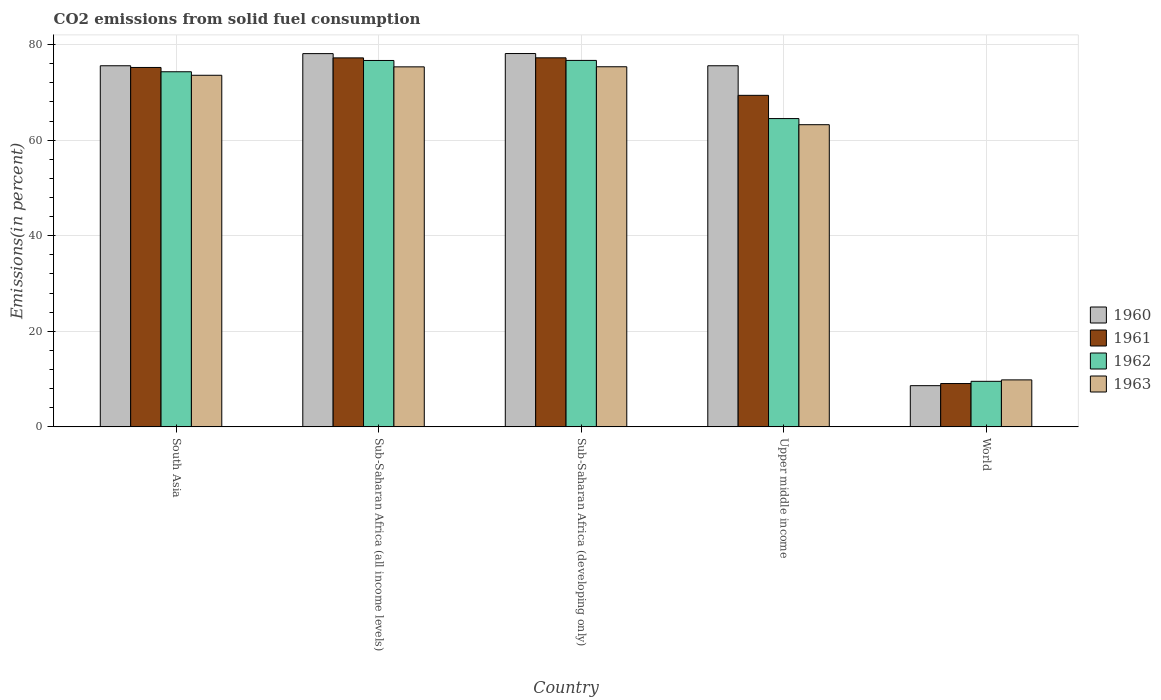How many groups of bars are there?
Offer a very short reply. 5. Are the number of bars per tick equal to the number of legend labels?
Your answer should be compact. Yes. Are the number of bars on each tick of the X-axis equal?
Ensure brevity in your answer.  Yes. What is the label of the 3rd group of bars from the left?
Give a very brief answer. Sub-Saharan Africa (developing only). What is the total CO2 emitted in 1960 in South Asia?
Give a very brief answer. 75.58. Across all countries, what is the maximum total CO2 emitted in 1963?
Offer a terse response. 75.37. Across all countries, what is the minimum total CO2 emitted in 1961?
Offer a terse response. 9.07. In which country was the total CO2 emitted in 1961 maximum?
Give a very brief answer. Sub-Saharan Africa (developing only). What is the total total CO2 emitted in 1962 in the graph?
Give a very brief answer. 301.78. What is the difference between the total CO2 emitted in 1963 in South Asia and that in World?
Your answer should be very brief. 63.76. What is the difference between the total CO2 emitted in 1961 in Sub-Saharan Africa (all income levels) and the total CO2 emitted in 1963 in World?
Provide a succinct answer. 67.4. What is the average total CO2 emitted in 1961 per country?
Provide a succinct answer. 61.63. What is the difference between the total CO2 emitted of/in 1961 and total CO2 emitted of/in 1962 in Upper middle income?
Your response must be concise. 4.86. What is the ratio of the total CO2 emitted in 1963 in Sub-Saharan Africa (all income levels) to that in World?
Offer a very short reply. 7.66. What is the difference between the highest and the second highest total CO2 emitted in 1963?
Your response must be concise. -1.76. What is the difference between the highest and the lowest total CO2 emitted in 1961?
Provide a succinct answer. 68.17. Is the sum of the total CO2 emitted in 1961 in South Asia and Upper middle income greater than the maximum total CO2 emitted in 1962 across all countries?
Your response must be concise. Yes. Is it the case that in every country, the sum of the total CO2 emitted in 1963 and total CO2 emitted in 1962 is greater than the sum of total CO2 emitted in 1961 and total CO2 emitted in 1960?
Make the answer very short. No. What does the 2nd bar from the left in Sub-Saharan Africa (developing only) represents?
Ensure brevity in your answer.  1961. How many bars are there?
Give a very brief answer. 20. How many countries are there in the graph?
Your response must be concise. 5. What is the difference between two consecutive major ticks on the Y-axis?
Give a very brief answer. 20. Are the values on the major ticks of Y-axis written in scientific E-notation?
Your answer should be compact. No. What is the title of the graph?
Give a very brief answer. CO2 emissions from solid fuel consumption. Does "1980" appear as one of the legend labels in the graph?
Provide a succinct answer. No. What is the label or title of the Y-axis?
Your answer should be very brief. Emissions(in percent). What is the Emissions(in percent) of 1960 in South Asia?
Offer a terse response. 75.58. What is the Emissions(in percent) of 1961 in South Asia?
Keep it short and to the point. 75.23. What is the Emissions(in percent) in 1962 in South Asia?
Provide a short and direct response. 74.33. What is the Emissions(in percent) of 1963 in South Asia?
Ensure brevity in your answer.  73.59. What is the Emissions(in percent) of 1960 in Sub-Saharan Africa (all income levels)?
Provide a succinct answer. 78.13. What is the Emissions(in percent) in 1961 in Sub-Saharan Africa (all income levels)?
Make the answer very short. 77.23. What is the Emissions(in percent) in 1962 in Sub-Saharan Africa (all income levels)?
Offer a very short reply. 76.69. What is the Emissions(in percent) of 1963 in Sub-Saharan Africa (all income levels)?
Give a very brief answer. 75.35. What is the Emissions(in percent) in 1960 in Sub-Saharan Africa (developing only)?
Provide a succinct answer. 78.14. What is the Emissions(in percent) of 1961 in Sub-Saharan Africa (developing only)?
Offer a terse response. 77.24. What is the Emissions(in percent) in 1962 in Sub-Saharan Africa (developing only)?
Keep it short and to the point. 76.7. What is the Emissions(in percent) in 1963 in Sub-Saharan Africa (developing only)?
Provide a short and direct response. 75.37. What is the Emissions(in percent) of 1960 in Upper middle income?
Make the answer very short. 75.58. What is the Emissions(in percent) in 1961 in Upper middle income?
Offer a very short reply. 69.39. What is the Emissions(in percent) in 1962 in Upper middle income?
Give a very brief answer. 64.53. What is the Emissions(in percent) in 1963 in Upper middle income?
Offer a terse response. 63.25. What is the Emissions(in percent) in 1960 in World?
Your response must be concise. 8.62. What is the Emissions(in percent) in 1961 in World?
Make the answer very short. 9.07. What is the Emissions(in percent) in 1962 in World?
Your answer should be compact. 9.53. What is the Emissions(in percent) in 1963 in World?
Keep it short and to the point. 9.83. Across all countries, what is the maximum Emissions(in percent) in 1960?
Offer a terse response. 78.14. Across all countries, what is the maximum Emissions(in percent) of 1961?
Your response must be concise. 77.24. Across all countries, what is the maximum Emissions(in percent) of 1962?
Your answer should be very brief. 76.7. Across all countries, what is the maximum Emissions(in percent) in 1963?
Offer a terse response. 75.37. Across all countries, what is the minimum Emissions(in percent) in 1960?
Your answer should be very brief. 8.62. Across all countries, what is the minimum Emissions(in percent) of 1961?
Offer a terse response. 9.07. Across all countries, what is the minimum Emissions(in percent) of 1962?
Your response must be concise. 9.53. Across all countries, what is the minimum Emissions(in percent) in 1963?
Provide a succinct answer. 9.83. What is the total Emissions(in percent) in 1960 in the graph?
Give a very brief answer. 316.05. What is the total Emissions(in percent) of 1961 in the graph?
Make the answer very short. 308.16. What is the total Emissions(in percent) of 1962 in the graph?
Keep it short and to the point. 301.78. What is the total Emissions(in percent) of 1963 in the graph?
Offer a very short reply. 297.4. What is the difference between the Emissions(in percent) in 1960 in South Asia and that in Sub-Saharan Africa (all income levels)?
Your answer should be compact. -2.54. What is the difference between the Emissions(in percent) of 1961 in South Asia and that in Sub-Saharan Africa (all income levels)?
Your answer should be compact. -2. What is the difference between the Emissions(in percent) in 1962 in South Asia and that in Sub-Saharan Africa (all income levels)?
Make the answer very short. -2.36. What is the difference between the Emissions(in percent) in 1963 in South Asia and that in Sub-Saharan Africa (all income levels)?
Provide a succinct answer. -1.76. What is the difference between the Emissions(in percent) in 1960 in South Asia and that in Sub-Saharan Africa (developing only)?
Give a very brief answer. -2.56. What is the difference between the Emissions(in percent) in 1961 in South Asia and that in Sub-Saharan Africa (developing only)?
Provide a short and direct response. -2.02. What is the difference between the Emissions(in percent) in 1962 in South Asia and that in Sub-Saharan Africa (developing only)?
Your answer should be compact. -2.37. What is the difference between the Emissions(in percent) of 1963 in South Asia and that in Sub-Saharan Africa (developing only)?
Give a very brief answer. -1.78. What is the difference between the Emissions(in percent) in 1960 in South Asia and that in Upper middle income?
Provide a short and direct response. 0. What is the difference between the Emissions(in percent) in 1961 in South Asia and that in Upper middle income?
Offer a terse response. 5.84. What is the difference between the Emissions(in percent) in 1962 in South Asia and that in Upper middle income?
Ensure brevity in your answer.  9.8. What is the difference between the Emissions(in percent) of 1963 in South Asia and that in Upper middle income?
Offer a terse response. 10.34. What is the difference between the Emissions(in percent) of 1960 in South Asia and that in World?
Give a very brief answer. 66.96. What is the difference between the Emissions(in percent) of 1961 in South Asia and that in World?
Your answer should be compact. 66.16. What is the difference between the Emissions(in percent) in 1962 in South Asia and that in World?
Your answer should be compact. 64.8. What is the difference between the Emissions(in percent) of 1963 in South Asia and that in World?
Provide a succinct answer. 63.76. What is the difference between the Emissions(in percent) in 1960 in Sub-Saharan Africa (all income levels) and that in Sub-Saharan Africa (developing only)?
Your answer should be very brief. -0.01. What is the difference between the Emissions(in percent) of 1961 in Sub-Saharan Africa (all income levels) and that in Sub-Saharan Africa (developing only)?
Offer a terse response. -0.01. What is the difference between the Emissions(in percent) in 1962 in Sub-Saharan Africa (all income levels) and that in Sub-Saharan Africa (developing only)?
Ensure brevity in your answer.  -0.01. What is the difference between the Emissions(in percent) in 1963 in Sub-Saharan Africa (all income levels) and that in Sub-Saharan Africa (developing only)?
Offer a terse response. -0.02. What is the difference between the Emissions(in percent) in 1960 in Sub-Saharan Africa (all income levels) and that in Upper middle income?
Offer a terse response. 2.54. What is the difference between the Emissions(in percent) of 1961 in Sub-Saharan Africa (all income levels) and that in Upper middle income?
Provide a succinct answer. 7.84. What is the difference between the Emissions(in percent) in 1962 in Sub-Saharan Africa (all income levels) and that in Upper middle income?
Offer a very short reply. 12.16. What is the difference between the Emissions(in percent) in 1963 in Sub-Saharan Africa (all income levels) and that in Upper middle income?
Ensure brevity in your answer.  12.11. What is the difference between the Emissions(in percent) of 1960 in Sub-Saharan Africa (all income levels) and that in World?
Offer a very short reply. 69.5. What is the difference between the Emissions(in percent) in 1961 in Sub-Saharan Africa (all income levels) and that in World?
Your answer should be compact. 68.16. What is the difference between the Emissions(in percent) in 1962 in Sub-Saharan Africa (all income levels) and that in World?
Make the answer very short. 67.15. What is the difference between the Emissions(in percent) in 1963 in Sub-Saharan Africa (all income levels) and that in World?
Your answer should be very brief. 65.52. What is the difference between the Emissions(in percent) of 1960 in Sub-Saharan Africa (developing only) and that in Upper middle income?
Give a very brief answer. 2.56. What is the difference between the Emissions(in percent) in 1961 in Sub-Saharan Africa (developing only) and that in Upper middle income?
Your answer should be very brief. 7.85. What is the difference between the Emissions(in percent) of 1962 in Sub-Saharan Africa (developing only) and that in Upper middle income?
Your response must be concise. 12.17. What is the difference between the Emissions(in percent) of 1963 in Sub-Saharan Africa (developing only) and that in Upper middle income?
Give a very brief answer. 12.13. What is the difference between the Emissions(in percent) in 1960 in Sub-Saharan Africa (developing only) and that in World?
Give a very brief answer. 69.52. What is the difference between the Emissions(in percent) of 1961 in Sub-Saharan Africa (developing only) and that in World?
Your response must be concise. 68.17. What is the difference between the Emissions(in percent) of 1962 in Sub-Saharan Africa (developing only) and that in World?
Provide a short and direct response. 67.17. What is the difference between the Emissions(in percent) in 1963 in Sub-Saharan Africa (developing only) and that in World?
Offer a very short reply. 65.54. What is the difference between the Emissions(in percent) in 1960 in Upper middle income and that in World?
Give a very brief answer. 66.96. What is the difference between the Emissions(in percent) of 1961 in Upper middle income and that in World?
Offer a terse response. 60.32. What is the difference between the Emissions(in percent) in 1962 in Upper middle income and that in World?
Offer a terse response. 55. What is the difference between the Emissions(in percent) of 1963 in Upper middle income and that in World?
Offer a very short reply. 53.41. What is the difference between the Emissions(in percent) of 1960 in South Asia and the Emissions(in percent) of 1961 in Sub-Saharan Africa (all income levels)?
Your answer should be very brief. -1.65. What is the difference between the Emissions(in percent) of 1960 in South Asia and the Emissions(in percent) of 1962 in Sub-Saharan Africa (all income levels)?
Ensure brevity in your answer.  -1.1. What is the difference between the Emissions(in percent) of 1960 in South Asia and the Emissions(in percent) of 1963 in Sub-Saharan Africa (all income levels)?
Make the answer very short. 0.23. What is the difference between the Emissions(in percent) in 1961 in South Asia and the Emissions(in percent) in 1962 in Sub-Saharan Africa (all income levels)?
Give a very brief answer. -1.46. What is the difference between the Emissions(in percent) in 1961 in South Asia and the Emissions(in percent) in 1963 in Sub-Saharan Africa (all income levels)?
Offer a terse response. -0.13. What is the difference between the Emissions(in percent) of 1962 in South Asia and the Emissions(in percent) of 1963 in Sub-Saharan Africa (all income levels)?
Offer a terse response. -1.03. What is the difference between the Emissions(in percent) in 1960 in South Asia and the Emissions(in percent) in 1961 in Sub-Saharan Africa (developing only)?
Provide a succinct answer. -1.66. What is the difference between the Emissions(in percent) of 1960 in South Asia and the Emissions(in percent) of 1962 in Sub-Saharan Africa (developing only)?
Provide a short and direct response. -1.12. What is the difference between the Emissions(in percent) in 1960 in South Asia and the Emissions(in percent) in 1963 in Sub-Saharan Africa (developing only)?
Give a very brief answer. 0.21. What is the difference between the Emissions(in percent) of 1961 in South Asia and the Emissions(in percent) of 1962 in Sub-Saharan Africa (developing only)?
Ensure brevity in your answer.  -1.47. What is the difference between the Emissions(in percent) in 1961 in South Asia and the Emissions(in percent) in 1963 in Sub-Saharan Africa (developing only)?
Your answer should be compact. -0.15. What is the difference between the Emissions(in percent) of 1962 in South Asia and the Emissions(in percent) of 1963 in Sub-Saharan Africa (developing only)?
Your response must be concise. -1.04. What is the difference between the Emissions(in percent) in 1960 in South Asia and the Emissions(in percent) in 1961 in Upper middle income?
Keep it short and to the point. 6.19. What is the difference between the Emissions(in percent) of 1960 in South Asia and the Emissions(in percent) of 1962 in Upper middle income?
Your answer should be compact. 11.05. What is the difference between the Emissions(in percent) of 1960 in South Asia and the Emissions(in percent) of 1963 in Upper middle income?
Offer a terse response. 12.33. What is the difference between the Emissions(in percent) of 1961 in South Asia and the Emissions(in percent) of 1962 in Upper middle income?
Provide a succinct answer. 10.7. What is the difference between the Emissions(in percent) of 1961 in South Asia and the Emissions(in percent) of 1963 in Upper middle income?
Your answer should be compact. 11.98. What is the difference between the Emissions(in percent) of 1962 in South Asia and the Emissions(in percent) of 1963 in Upper middle income?
Give a very brief answer. 11.08. What is the difference between the Emissions(in percent) of 1960 in South Asia and the Emissions(in percent) of 1961 in World?
Keep it short and to the point. 66.51. What is the difference between the Emissions(in percent) of 1960 in South Asia and the Emissions(in percent) of 1962 in World?
Ensure brevity in your answer.  66.05. What is the difference between the Emissions(in percent) in 1960 in South Asia and the Emissions(in percent) in 1963 in World?
Your answer should be compact. 65.75. What is the difference between the Emissions(in percent) of 1961 in South Asia and the Emissions(in percent) of 1962 in World?
Offer a very short reply. 65.69. What is the difference between the Emissions(in percent) in 1961 in South Asia and the Emissions(in percent) in 1963 in World?
Offer a terse response. 65.39. What is the difference between the Emissions(in percent) of 1962 in South Asia and the Emissions(in percent) of 1963 in World?
Keep it short and to the point. 64.49. What is the difference between the Emissions(in percent) of 1960 in Sub-Saharan Africa (all income levels) and the Emissions(in percent) of 1961 in Sub-Saharan Africa (developing only)?
Your answer should be very brief. 0.88. What is the difference between the Emissions(in percent) of 1960 in Sub-Saharan Africa (all income levels) and the Emissions(in percent) of 1962 in Sub-Saharan Africa (developing only)?
Offer a very short reply. 1.42. What is the difference between the Emissions(in percent) of 1960 in Sub-Saharan Africa (all income levels) and the Emissions(in percent) of 1963 in Sub-Saharan Africa (developing only)?
Keep it short and to the point. 2.75. What is the difference between the Emissions(in percent) in 1961 in Sub-Saharan Africa (all income levels) and the Emissions(in percent) in 1962 in Sub-Saharan Africa (developing only)?
Offer a terse response. 0.53. What is the difference between the Emissions(in percent) in 1961 in Sub-Saharan Africa (all income levels) and the Emissions(in percent) in 1963 in Sub-Saharan Africa (developing only)?
Give a very brief answer. 1.86. What is the difference between the Emissions(in percent) in 1962 in Sub-Saharan Africa (all income levels) and the Emissions(in percent) in 1963 in Sub-Saharan Africa (developing only)?
Your answer should be compact. 1.31. What is the difference between the Emissions(in percent) in 1960 in Sub-Saharan Africa (all income levels) and the Emissions(in percent) in 1961 in Upper middle income?
Offer a very short reply. 8.73. What is the difference between the Emissions(in percent) in 1960 in Sub-Saharan Africa (all income levels) and the Emissions(in percent) in 1962 in Upper middle income?
Provide a succinct answer. 13.6. What is the difference between the Emissions(in percent) of 1960 in Sub-Saharan Africa (all income levels) and the Emissions(in percent) of 1963 in Upper middle income?
Provide a succinct answer. 14.88. What is the difference between the Emissions(in percent) of 1961 in Sub-Saharan Africa (all income levels) and the Emissions(in percent) of 1962 in Upper middle income?
Provide a succinct answer. 12.7. What is the difference between the Emissions(in percent) of 1961 in Sub-Saharan Africa (all income levels) and the Emissions(in percent) of 1963 in Upper middle income?
Offer a terse response. 13.98. What is the difference between the Emissions(in percent) of 1962 in Sub-Saharan Africa (all income levels) and the Emissions(in percent) of 1963 in Upper middle income?
Ensure brevity in your answer.  13.44. What is the difference between the Emissions(in percent) of 1960 in Sub-Saharan Africa (all income levels) and the Emissions(in percent) of 1961 in World?
Offer a very short reply. 69.06. What is the difference between the Emissions(in percent) in 1960 in Sub-Saharan Africa (all income levels) and the Emissions(in percent) in 1962 in World?
Your answer should be compact. 68.59. What is the difference between the Emissions(in percent) of 1960 in Sub-Saharan Africa (all income levels) and the Emissions(in percent) of 1963 in World?
Ensure brevity in your answer.  68.29. What is the difference between the Emissions(in percent) in 1961 in Sub-Saharan Africa (all income levels) and the Emissions(in percent) in 1962 in World?
Keep it short and to the point. 67.7. What is the difference between the Emissions(in percent) in 1961 in Sub-Saharan Africa (all income levels) and the Emissions(in percent) in 1963 in World?
Ensure brevity in your answer.  67.4. What is the difference between the Emissions(in percent) of 1962 in Sub-Saharan Africa (all income levels) and the Emissions(in percent) of 1963 in World?
Offer a terse response. 66.85. What is the difference between the Emissions(in percent) of 1960 in Sub-Saharan Africa (developing only) and the Emissions(in percent) of 1961 in Upper middle income?
Your answer should be compact. 8.75. What is the difference between the Emissions(in percent) of 1960 in Sub-Saharan Africa (developing only) and the Emissions(in percent) of 1962 in Upper middle income?
Your answer should be very brief. 13.61. What is the difference between the Emissions(in percent) in 1960 in Sub-Saharan Africa (developing only) and the Emissions(in percent) in 1963 in Upper middle income?
Provide a short and direct response. 14.89. What is the difference between the Emissions(in percent) in 1961 in Sub-Saharan Africa (developing only) and the Emissions(in percent) in 1962 in Upper middle income?
Make the answer very short. 12.71. What is the difference between the Emissions(in percent) in 1961 in Sub-Saharan Africa (developing only) and the Emissions(in percent) in 1963 in Upper middle income?
Keep it short and to the point. 14. What is the difference between the Emissions(in percent) in 1962 in Sub-Saharan Africa (developing only) and the Emissions(in percent) in 1963 in Upper middle income?
Ensure brevity in your answer.  13.45. What is the difference between the Emissions(in percent) in 1960 in Sub-Saharan Africa (developing only) and the Emissions(in percent) in 1961 in World?
Give a very brief answer. 69.07. What is the difference between the Emissions(in percent) of 1960 in Sub-Saharan Africa (developing only) and the Emissions(in percent) of 1962 in World?
Keep it short and to the point. 68.61. What is the difference between the Emissions(in percent) of 1960 in Sub-Saharan Africa (developing only) and the Emissions(in percent) of 1963 in World?
Keep it short and to the point. 68.31. What is the difference between the Emissions(in percent) of 1961 in Sub-Saharan Africa (developing only) and the Emissions(in percent) of 1962 in World?
Provide a short and direct response. 67.71. What is the difference between the Emissions(in percent) of 1961 in Sub-Saharan Africa (developing only) and the Emissions(in percent) of 1963 in World?
Keep it short and to the point. 67.41. What is the difference between the Emissions(in percent) of 1962 in Sub-Saharan Africa (developing only) and the Emissions(in percent) of 1963 in World?
Your response must be concise. 66.87. What is the difference between the Emissions(in percent) in 1960 in Upper middle income and the Emissions(in percent) in 1961 in World?
Offer a very short reply. 66.51. What is the difference between the Emissions(in percent) in 1960 in Upper middle income and the Emissions(in percent) in 1962 in World?
Your answer should be very brief. 66.05. What is the difference between the Emissions(in percent) of 1960 in Upper middle income and the Emissions(in percent) of 1963 in World?
Your answer should be compact. 65.75. What is the difference between the Emissions(in percent) of 1961 in Upper middle income and the Emissions(in percent) of 1962 in World?
Keep it short and to the point. 59.86. What is the difference between the Emissions(in percent) of 1961 in Upper middle income and the Emissions(in percent) of 1963 in World?
Your response must be concise. 59.56. What is the difference between the Emissions(in percent) in 1962 in Upper middle income and the Emissions(in percent) in 1963 in World?
Keep it short and to the point. 54.7. What is the average Emissions(in percent) of 1960 per country?
Your answer should be compact. 63.21. What is the average Emissions(in percent) in 1961 per country?
Your response must be concise. 61.63. What is the average Emissions(in percent) of 1962 per country?
Provide a succinct answer. 60.36. What is the average Emissions(in percent) of 1963 per country?
Ensure brevity in your answer.  59.48. What is the difference between the Emissions(in percent) of 1960 and Emissions(in percent) of 1961 in South Asia?
Offer a very short reply. 0.36. What is the difference between the Emissions(in percent) in 1960 and Emissions(in percent) in 1962 in South Asia?
Your response must be concise. 1.25. What is the difference between the Emissions(in percent) of 1960 and Emissions(in percent) of 1963 in South Asia?
Provide a succinct answer. 1.99. What is the difference between the Emissions(in percent) in 1961 and Emissions(in percent) in 1962 in South Asia?
Keep it short and to the point. 0.9. What is the difference between the Emissions(in percent) of 1961 and Emissions(in percent) of 1963 in South Asia?
Offer a terse response. 1.63. What is the difference between the Emissions(in percent) of 1962 and Emissions(in percent) of 1963 in South Asia?
Your answer should be very brief. 0.74. What is the difference between the Emissions(in percent) of 1960 and Emissions(in percent) of 1961 in Sub-Saharan Africa (all income levels)?
Ensure brevity in your answer.  0.9. What is the difference between the Emissions(in percent) of 1960 and Emissions(in percent) of 1962 in Sub-Saharan Africa (all income levels)?
Your answer should be compact. 1.44. What is the difference between the Emissions(in percent) of 1960 and Emissions(in percent) of 1963 in Sub-Saharan Africa (all income levels)?
Keep it short and to the point. 2.77. What is the difference between the Emissions(in percent) in 1961 and Emissions(in percent) in 1962 in Sub-Saharan Africa (all income levels)?
Give a very brief answer. 0.54. What is the difference between the Emissions(in percent) of 1961 and Emissions(in percent) of 1963 in Sub-Saharan Africa (all income levels)?
Provide a succinct answer. 1.88. What is the difference between the Emissions(in percent) of 1962 and Emissions(in percent) of 1963 in Sub-Saharan Africa (all income levels)?
Provide a succinct answer. 1.33. What is the difference between the Emissions(in percent) in 1960 and Emissions(in percent) in 1961 in Sub-Saharan Africa (developing only)?
Offer a terse response. 0.9. What is the difference between the Emissions(in percent) of 1960 and Emissions(in percent) of 1962 in Sub-Saharan Africa (developing only)?
Ensure brevity in your answer.  1.44. What is the difference between the Emissions(in percent) in 1960 and Emissions(in percent) in 1963 in Sub-Saharan Africa (developing only)?
Your response must be concise. 2.77. What is the difference between the Emissions(in percent) of 1961 and Emissions(in percent) of 1962 in Sub-Saharan Africa (developing only)?
Provide a short and direct response. 0.54. What is the difference between the Emissions(in percent) in 1961 and Emissions(in percent) in 1963 in Sub-Saharan Africa (developing only)?
Provide a short and direct response. 1.87. What is the difference between the Emissions(in percent) in 1962 and Emissions(in percent) in 1963 in Sub-Saharan Africa (developing only)?
Offer a very short reply. 1.33. What is the difference between the Emissions(in percent) in 1960 and Emissions(in percent) in 1961 in Upper middle income?
Offer a very short reply. 6.19. What is the difference between the Emissions(in percent) in 1960 and Emissions(in percent) in 1962 in Upper middle income?
Your answer should be very brief. 11.05. What is the difference between the Emissions(in percent) in 1960 and Emissions(in percent) in 1963 in Upper middle income?
Your response must be concise. 12.33. What is the difference between the Emissions(in percent) of 1961 and Emissions(in percent) of 1962 in Upper middle income?
Provide a short and direct response. 4.86. What is the difference between the Emissions(in percent) of 1961 and Emissions(in percent) of 1963 in Upper middle income?
Your answer should be very brief. 6.14. What is the difference between the Emissions(in percent) of 1962 and Emissions(in percent) of 1963 in Upper middle income?
Provide a succinct answer. 1.28. What is the difference between the Emissions(in percent) in 1960 and Emissions(in percent) in 1961 in World?
Make the answer very short. -0.45. What is the difference between the Emissions(in percent) of 1960 and Emissions(in percent) of 1962 in World?
Make the answer very short. -0.91. What is the difference between the Emissions(in percent) of 1960 and Emissions(in percent) of 1963 in World?
Your answer should be compact. -1.21. What is the difference between the Emissions(in percent) in 1961 and Emissions(in percent) in 1962 in World?
Offer a very short reply. -0.46. What is the difference between the Emissions(in percent) in 1961 and Emissions(in percent) in 1963 in World?
Offer a terse response. -0.77. What is the difference between the Emissions(in percent) in 1962 and Emissions(in percent) in 1963 in World?
Provide a short and direct response. -0.3. What is the ratio of the Emissions(in percent) of 1960 in South Asia to that in Sub-Saharan Africa (all income levels)?
Make the answer very short. 0.97. What is the ratio of the Emissions(in percent) in 1961 in South Asia to that in Sub-Saharan Africa (all income levels)?
Offer a very short reply. 0.97. What is the ratio of the Emissions(in percent) of 1962 in South Asia to that in Sub-Saharan Africa (all income levels)?
Your answer should be very brief. 0.97. What is the ratio of the Emissions(in percent) in 1963 in South Asia to that in Sub-Saharan Africa (all income levels)?
Your answer should be very brief. 0.98. What is the ratio of the Emissions(in percent) of 1960 in South Asia to that in Sub-Saharan Africa (developing only)?
Keep it short and to the point. 0.97. What is the ratio of the Emissions(in percent) of 1961 in South Asia to that in Sub-Saharan Africa (developing only)?
Make the answer very short. 0.97. What is the ratio of the Emissions(in percent) of 1962 in South Asia to that in Sub-Saharan Africa (developing only)?
Offer a terse response. 0.97. What is the ratio of the Emissions(in percent) in 1963 in South Asia to that in Sub-Saharan Africa (developing only)?
Make the answer very short. 0.98. What is the ratio of the Emissions(in percent) in 1960 in South Asia to that in Upper middle income?
Keep it short and to the point. 1. What is the ratio of the Emissions(in percent) of 1961 in South Asia to that in Upper middle income?
Provide a short and direct response. 1.08. What is the ratio of the Emissions(in percent) of 1962 in South Asia to that in Upper middle income?
Offer a very short reply. 1.15. What is the ratio of the Emissions(in percent) of 1963 in South Asia to that in Upper middle income?
Ensure brevity in your answer.  1.16. What is the ratio of the Emissions(in percent) of 1960 in South Asia to that in World?
Provide a succinct answer. 8.76. What is the ratio of the Emissions(in percent) of 1961 in South Asia to that in World?
Your response must be concise. 8.29. What is the ratio of the Emissions(in percent) of 1962 in South Asia to that in World?
Give a very brief answer. 7.8. What is the ratio of the Emissions(in percent) in 1963 in South Asia to that in World?
Your answer should be very brief. 7.48. What is the ratio of the Emissions(in percent) in 1960 in Sub-Saharan Africa (all income levels) to that in Sub-Saharan Africa (developing only)?
Provide a succinct answer. 1. What is the ratio of the Emissions(in percent) in 1961 in Sub-Saharan Africa (all income levels) to that in Sub-Saharan Africa (developing only)?
Provide a short and direct response. 1. What is the ratio of the Emissions(in percent) in 1962 in Sub-Saharan Africa (all income levels) to that in Sub-Saharan Africa (developing only)?
Keep it short and to the point. 1. What is the ratio of the Emissions(in percent) in 1963 in Sub-Saharan Africa (all income levels) to that in Sub-Saharan Africa (developing only)?
Make the answer very short. 1. What is the ratio of the Emissions(in percent) in 1960 in Sub-Saharan Africa (all income levels) to that in Upper middle income?
Keep it short and to the point. 1.03. What is the ratio of the Emissions(in percent) of 1961 in Sub-Saharan Africa (all income levels) to that in Upper middle income?
Ensure brevity in your answer.  1.11. What is the ratio of the Emissions(in percent) of 1962 in Sub-Saharan Africa (all income levels) to that in Upper middle income?
Provide a succinct answer. 1.19. What is the ratio of the Emissions(in percent) in 1963 in Sub-Saharan Africa (all income levels) to that in Upper middle income?
Offer a terse response. 1.19. What is the ratio of the Emissions(in percent) of 1960 in Sub-Saharan Africa (all income levels) to that in World?
Your response must be concise. 9.06. What is the ratio of the Emissions(in percent) of 1961 in Sub-Saharan Africa (all income levels) to that in World?
Keep it short and to the point. 8.52. What is the ratio of the Emissions(in percent) of 1962 in Sub-Saharan Africa (all income levels) to that in World?
Offer a very short reply. 8.04. What is the ratio of the Emissions(in percent) in 1963 in Sub-Saharan Africa (all income levels) to that in World?
Ensure brevity in your answer.  7.66. What is the ratio of the Emissions(in percent) in 1960 in Sub-Saharan Africa (developing only) to that in Upper middle income?
Make the answer very short. 1.03. What is the ratio of the Emissions(in percent) in 1961 in Sub-Saharan Africa (developing only) to that in Upper middle income?
Your answer should be very brief. 1.11. What is the ratio of the Emissions(in percent) in 1962 in Sub-Saharan Africa (developing only) to that in Upper middle income?
Offer a terse response. 1.19. What is the ratio of the Emissions(in percent) of 1963 in Sub-Saharan Africa (developing only) to that in Upper middle income?
Provide a succinct answer. 1.19. What is the ratio of the Emissions(in percent) in 1960 in Sub-Saharan Africa (developing only) to that in World?
Make the answer very short. 9.06. What is the ratio of the Emissions(in percent) of 1961 in Sub-Saharan Africa (developing only) to that in World?
Your response must be concise. 8.52. What is the ratio of the Emissions(in percent) in 1962 in Sub-Saharan Africa (developing only) to that in World?
Give a very brief answer. 8.05. What is the ratio of the Emissions(in percent) of 1963 in Sub-Saharan Africa (developing only) to that in World?
Your answer should be compact. 7.66. What is the ratio of the Emissions(in percent) in 1960 in Upper middle income to that in World?
Provide a succinct answer. 8.76. What is the ratio of the Emissions(in percent) in 1961 in Upper middle income to that in World?
Offer a very short reply. 7.65. What is the ratio of the Emissions(in percent) of 1962 in Upper middle income to that in World?
Give a very brief answer. 6.77. What is the ratio of the Emissions(in percent) of 1963 in Upper middle income to that in World?
Keep it short and to the point. 6.43. What is the difference between the highest and the second highest Emissions(in percent) of 1960?
Ensure brevity in your answer.  0.01. What is the difference between the highest and the second highest Emissions(in percent) in 1961?
Keep it short and to the point. 0.01. What is the difference between the highest and the second highest Emissions(in percent) in 1962?
Your answer should be compact. 0.01. What is the difference between the highest and the second highest Emissions(in percent) in 1963?
Offer a very short reply. 0.02. What is the difference between the highest and the lowest Emissions(in percent) of 1960?
Your answer should be very brief. 69.52. What is the difference between the highest and the lowest Emissions(in percent) in 1961?
Offer a very short reply. 68.17. What is the difference between the highest and the lowest Emissions(in percent) of 1962?
Provide a succinct answer. 67.17. What is the difference between the highest and the lowest Emissions(in percent) in 1963?
Ensure brevity in your answer.  65.54. 